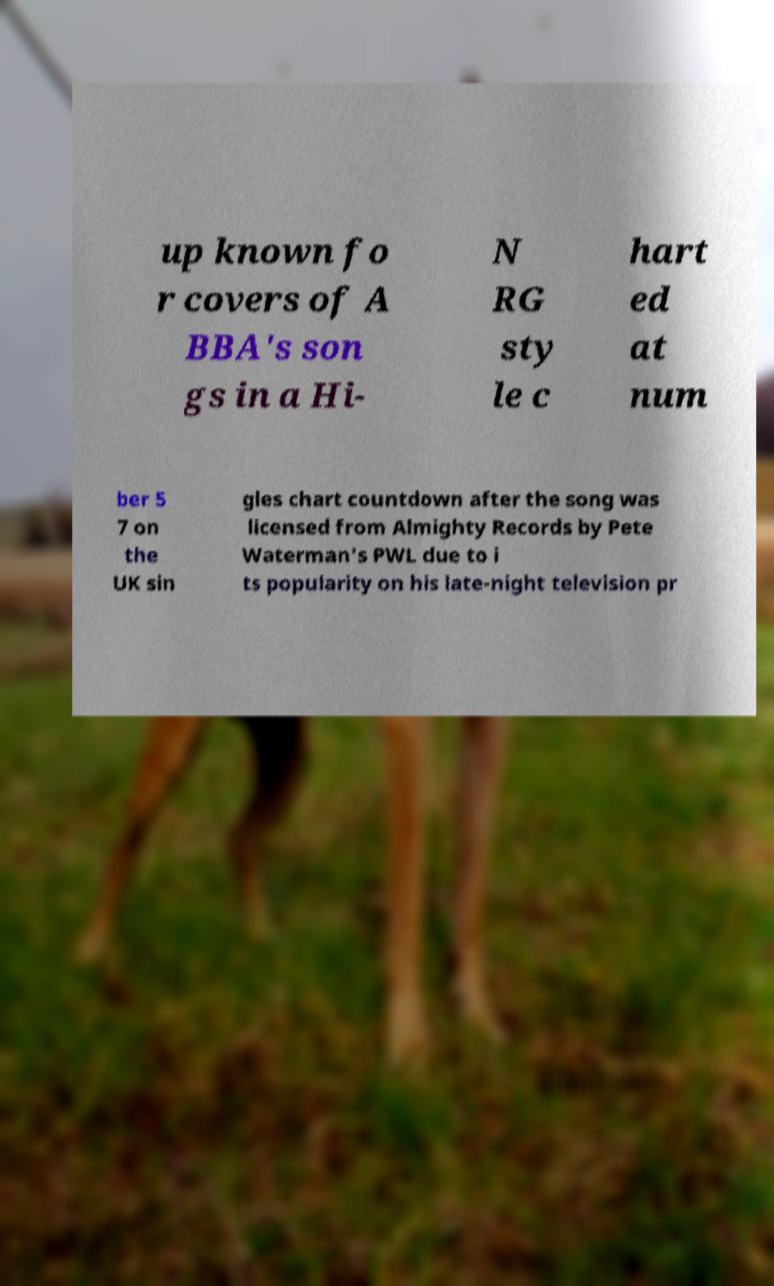Please read and relay the text visible in this image. What does it say? up known fo r covers of A BBA's son gs in a Hi- N RG sty le c hart ed at num ber 5 7 on the UK sin gles chart countdown after the song was licensed from Almighty Records by Pete Waterman's PWL due to i ts popularity on his late-night television pr 